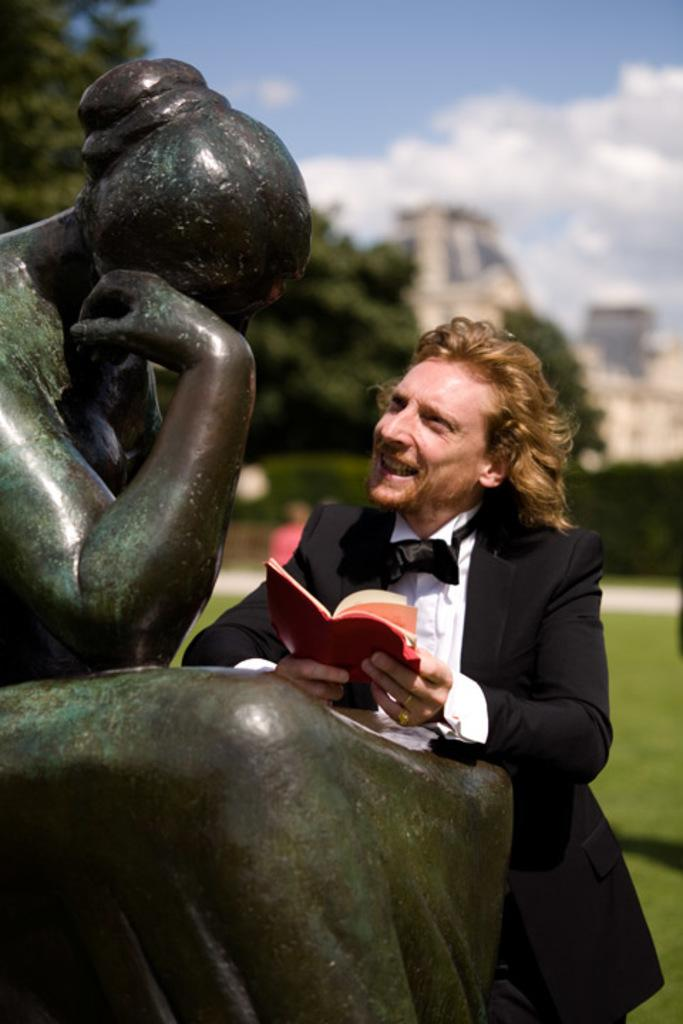What is the main subject in the image? There is a statue in the image. Who or what is beside the statue? A person is standing beside the statue. What is the person holding? The person is holding a book. Can you describe the background of the image? The background of the image is blurred, and there are trees, grass, and a cloudy sky visible. What type of boat can be seen in the image? There is no boat present in the image. What kind of furniture is being used by the person in the image? There is no furniture visible in the image; the person is standing beside the statue. 